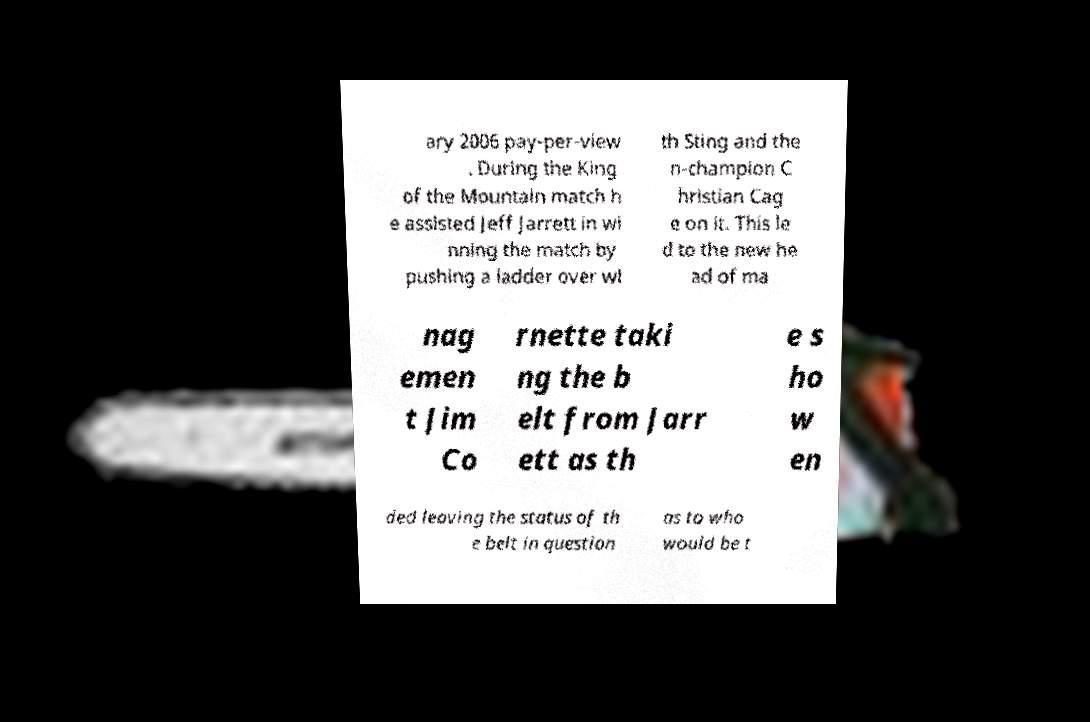Could you assist in decoding the text presented in this image and type it out clearly? ary 2006 pay-per-view . During the King of the Mountain match h e assisted Jeff Jarrett in wi nning the match by pushing a ladder over wi th Sting and the n-champion C hristian Cag e on it. This le d to the new he ad of ma nag emen t Jim Co rnette taki ng the b elt from Jarr ett as th e s ho w en ded leaving the status of th e belt in question as to who would be t 